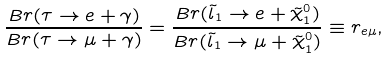Convert formula to latex. <formula><loc_0><loc_0><loc_500><loc_500>\frac { B r ( \tau \to e + \gamma ) } { B r ( \tau \to \mu + \gamma ) } = \frac { B r ( \tilde { l } _ { 1 } \to e + \tilde { \chi } _ { 1 } ^ { 0 } ) } { B r ( \tilde { l } _ { 1 } \to \mu + \tilde { \chi } ^ { 0 } _ { 1 } ) } \equiv r _ { e \mu } ,</formula> 